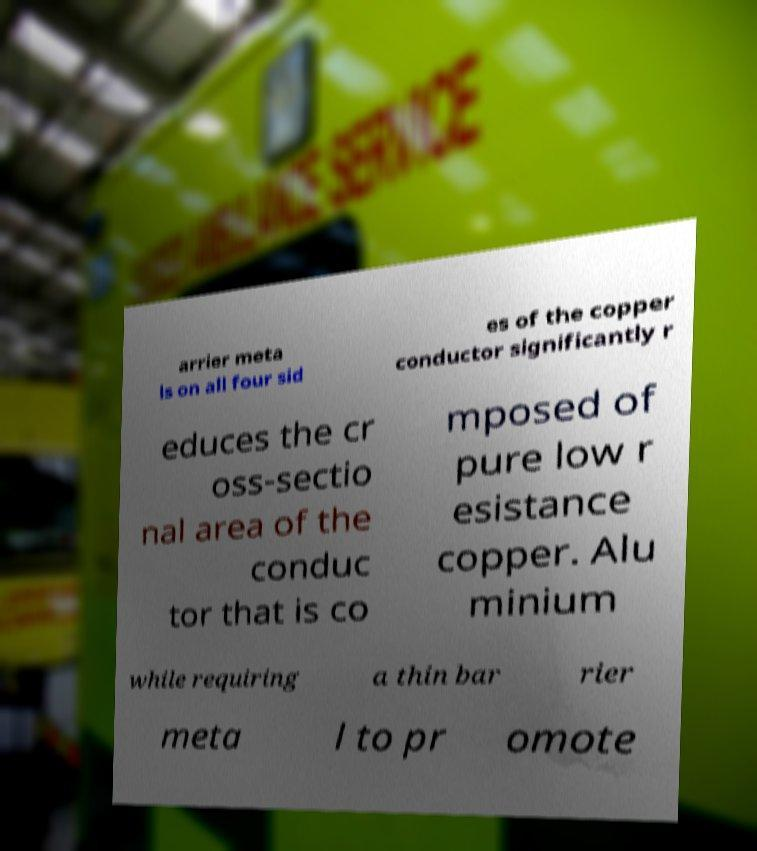Please identify and transcribe the text found in this image. arrier meta ls on all four sid es of the copper conductor significantly r educes the cr oss-sectio nal area of the conduc tor that is co mposed of pure low r esistance copper. Alu minium while requiring a thin bar rier meta l to pr omote 